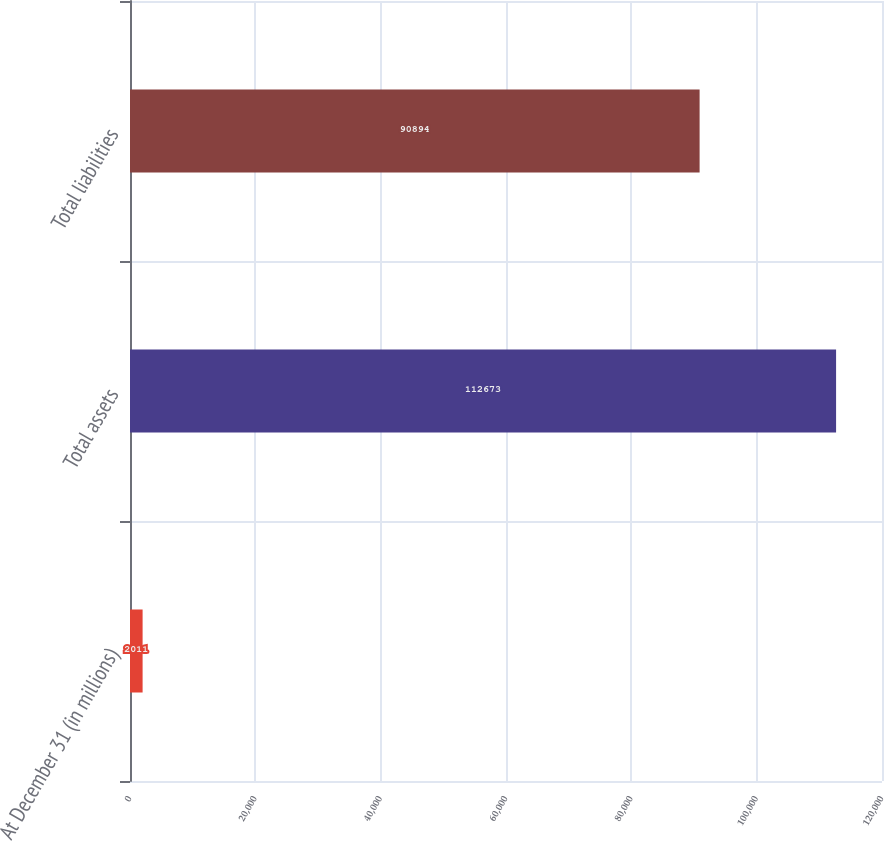Convert chart to OTSL. <chart><loc_0><loc_0><loc_500><loc_500><bar_chart><fcel>At December 31 (in millions)<fcel>Total assets<fcel>Total liabilities<nl><fcel>2011<fcel>112673<fcel>90894<nl></chart> 